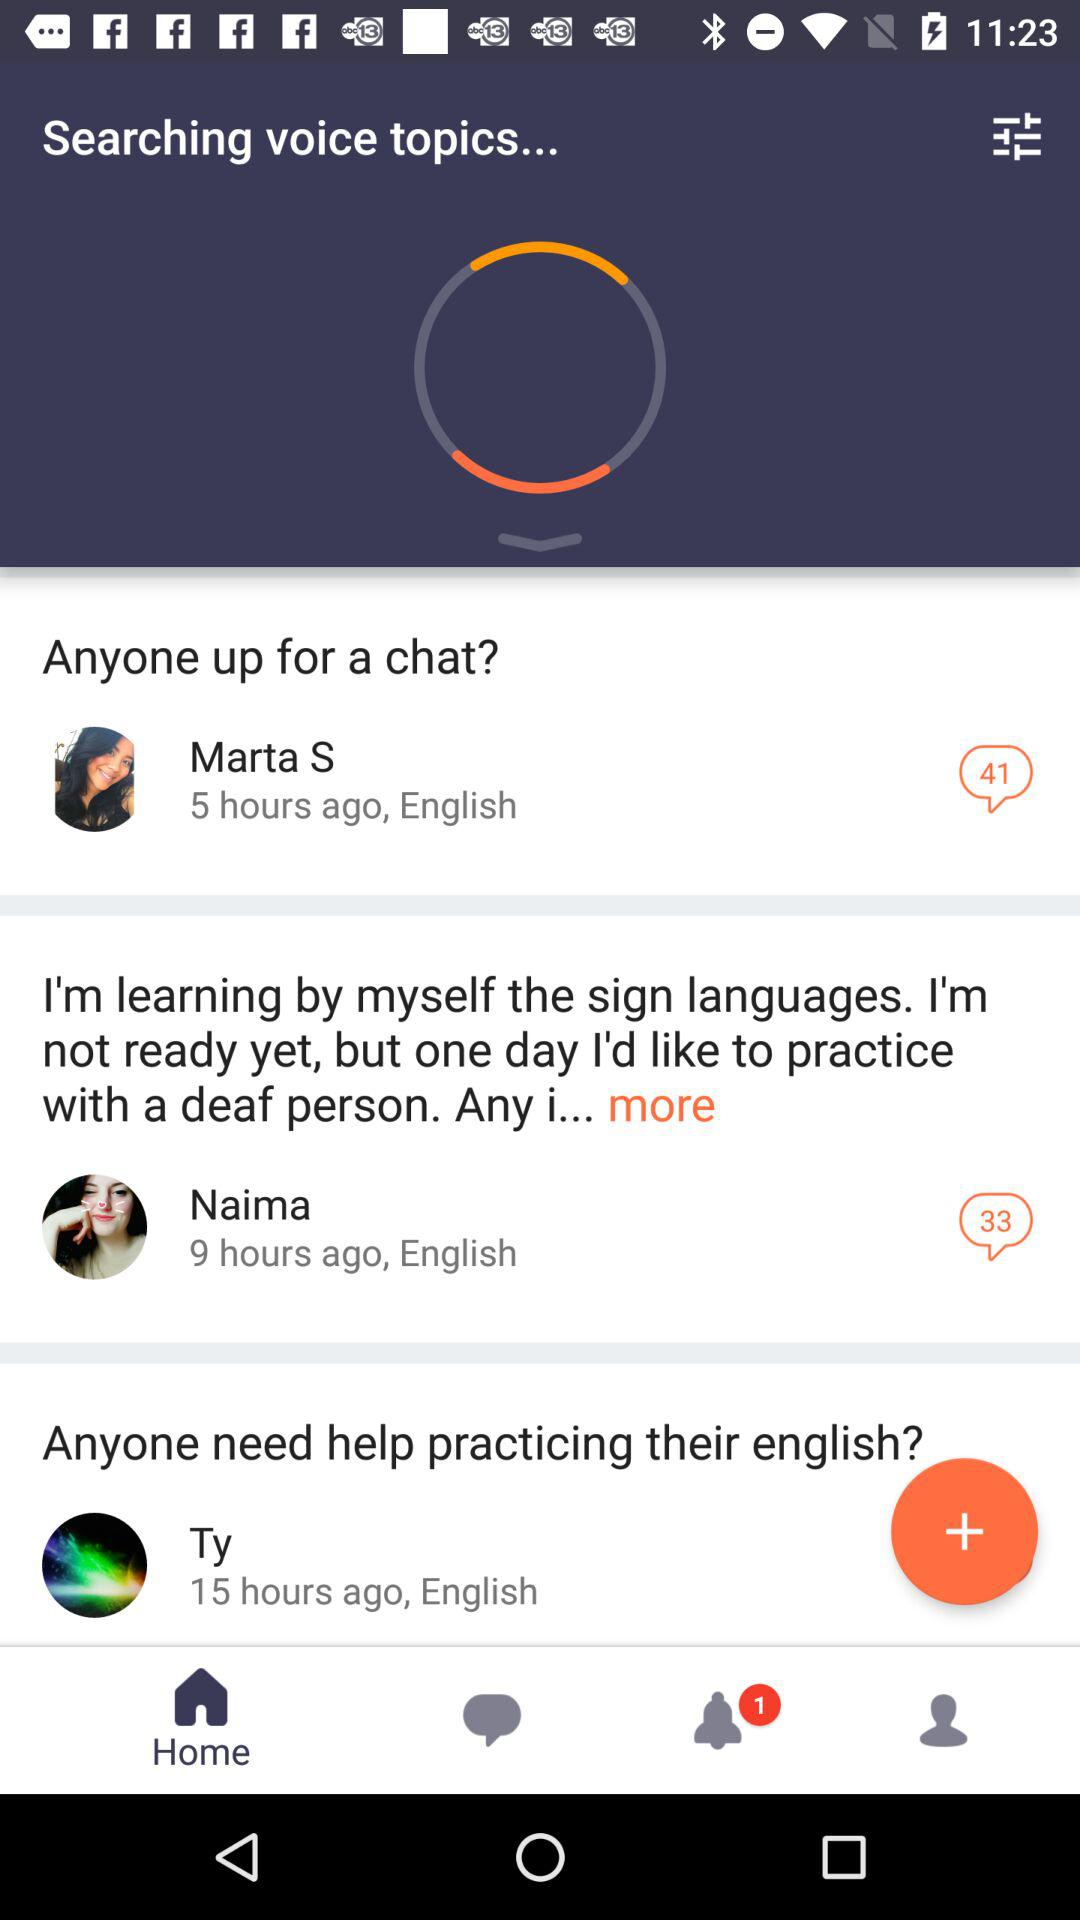What is the number of notifications? There is 1 notification. 